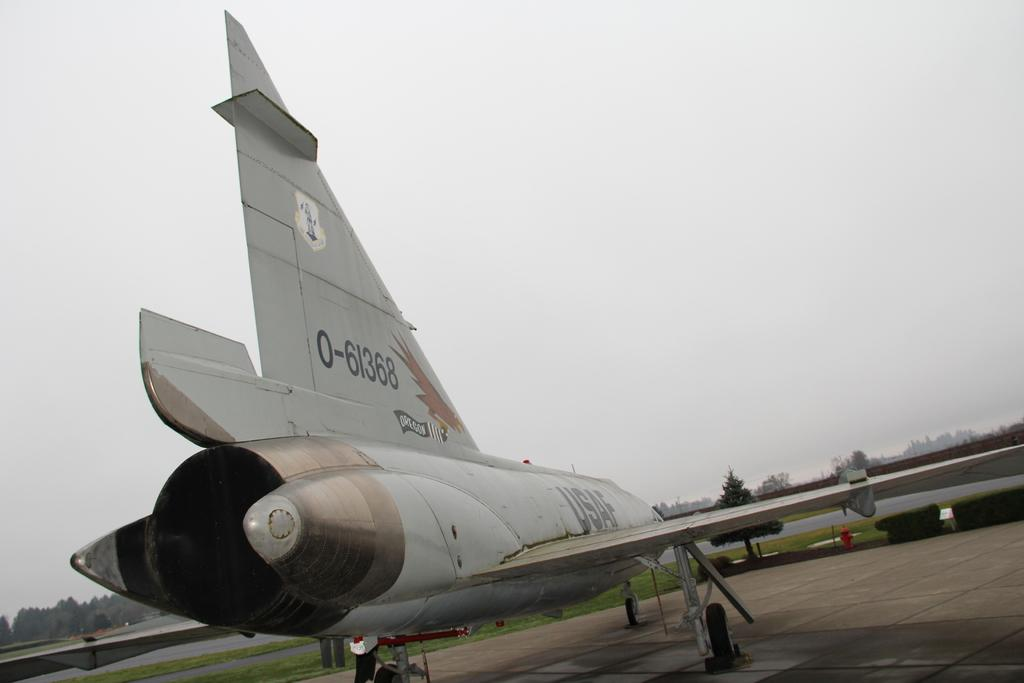Provide a one-sentence caption for the provided image. A grey plane is designated by 0-61368 on the tail. 